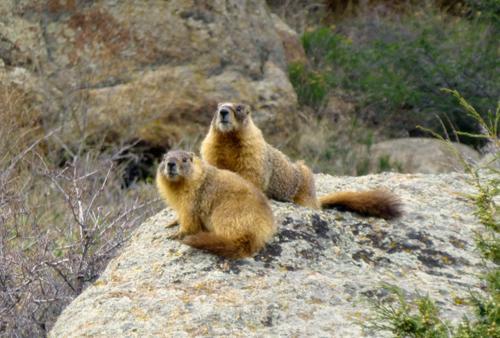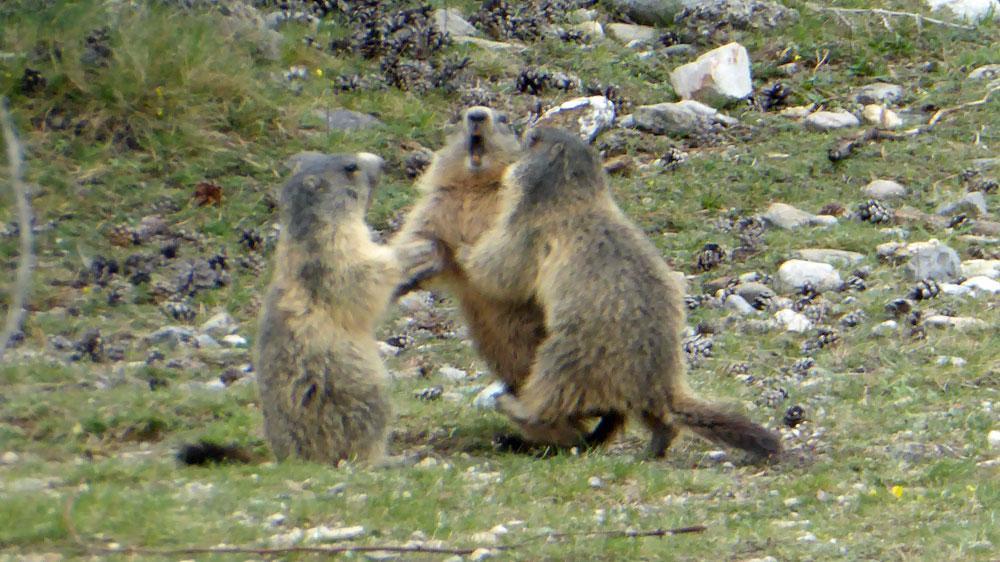The first image is the image on the left, the second image is the image on the right. For the images shown, is this caption "Right image shows two marmots on all fours posed face-to-face." true? Answer yes or no. No. The first image is the image on the left, the second image is the image on the right. Given the left and right images, does the statement "Two animals are interacting in a field in both images." hold true? Answer yes or no. No. 